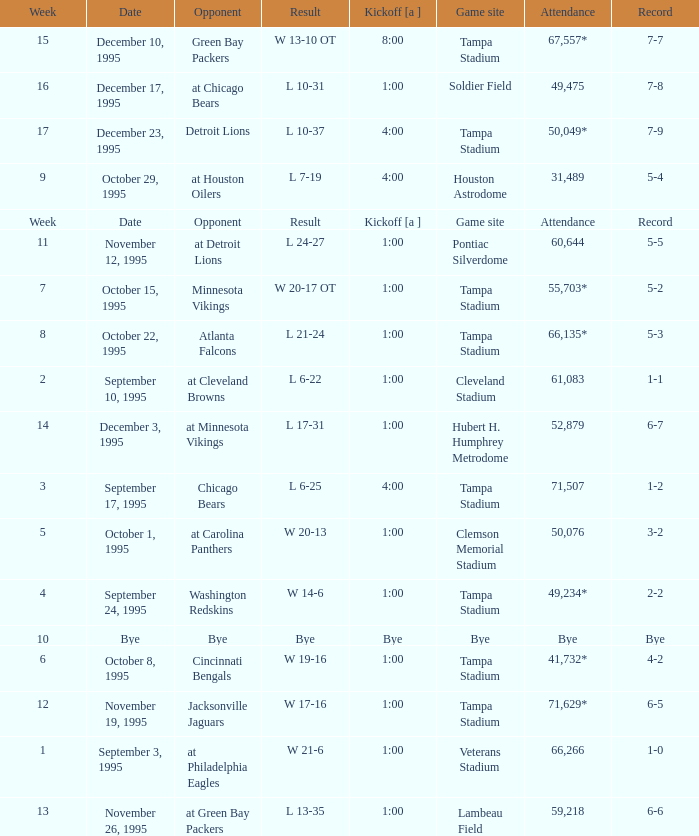On what date was Tampa Bay's Week 4 game? September 24, 1995. 